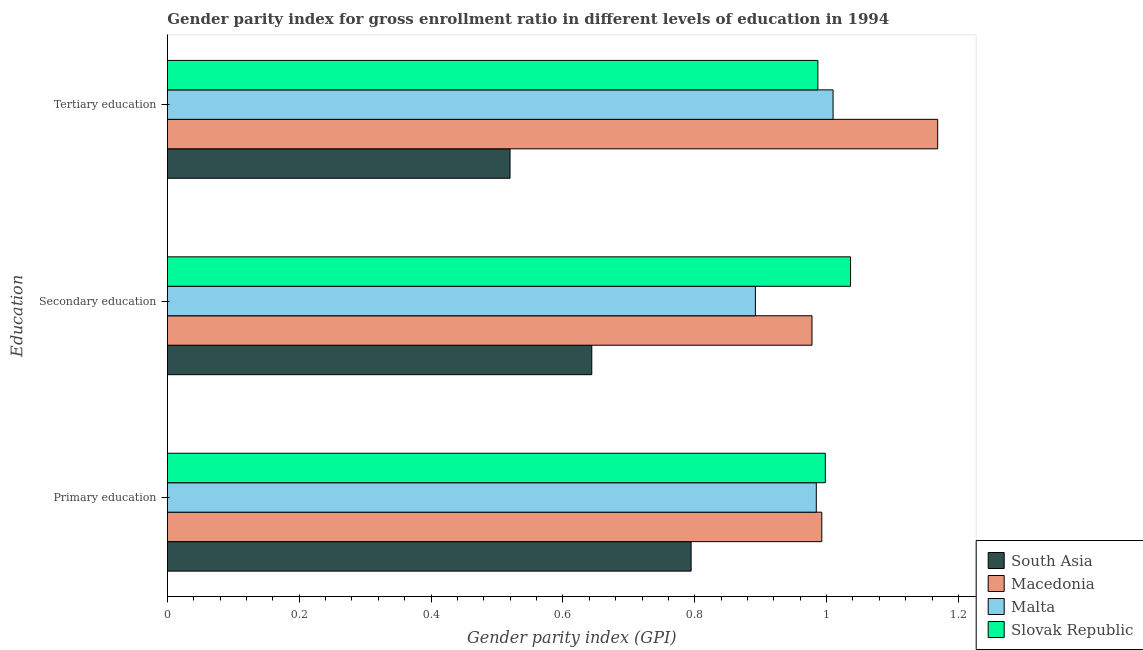How many different coloured bars are there?
Your answer should be compact. 4. How many bars are there on the 3rd tick from the bottom?
Provide a succinct answer. 4. What is the label of the 2nd group of bars from the top?
Offer a very short reply. Secondary education. What is the gender parity index in tertiary education in Macedonia?
Keep it short and to the point. 1.17. Across all countries, what is the maximum gender parity index in primary education?
Ensure brevity in your answer.  1. Across all countries, what is the minimum gender parity index in tertiary education?
Your response must be concise. 0.52. In which country was the gender parity index in secondary education maximum?
Provide a short and direct response. Slovak Republic. In which country was the gender parity index in secondary education minimum?
Your response must be concise. South Asia. What is the total gender parity index in tertiary education in the graph?
Provide a short and direct response. 3.68. What is the difference between the gender parity index in primary education in Slovak Republic and that in Macedonia?
Offer a terse response. 0.01. What is the difference between the gender parity index in tertiary education in Macedonia and the gender parity index in primary education in Malta?
Ensure brevity in your answer.  0.18. What is the average gender parity index in secondary education per country?
Keep it short and to the point. 0.89. What is the difference between the gender parity index in tertiary education and gender parity index in secondary education in Malta?
Ensure brevity in your answer.  0.12. In how many countries, is the gender parity index in secondary education greater than 0.36 ?
Your response must be concise. 4. What is the ratio of the gender parity index in tertiary education in South Asia to that in Slovak Republic?
Give a very brief answer. 0.53. Is the gender parity index in tertiary education in Macedonia less than that in Malta?
Offer a terse response. No. What is the difference between the highest and the second highest gender parity index in tertiary education?
Ensure brevity in your answer.  0.16. What is the difference between the highest and the lowest gender parity index in tertiary education?
Give a very brief answer. 0.65. What does the 1st bar from the top in Primary education represents?
Keep it short and to the point. Slovak Republic. What does the 4th bar from the bottom in Secondary education represents?
Offer a very short reply. Slovak Republic. Is it the case that in every country, the sum of the gender parity index in primary education and gender parity index in secondary education is greater than the gender parity index in tertiary education?
Make the answer very short. Yes. How many bars are there?
Ensure brevity in your answer.  12. Are all the bars in the graph horizontal?
Offer a very short reply. Yes. What is the difference between two consecutive major ticks on the X-axis?
Make the answer very short. 0.2. Does the graph contain any zero values?
Offer a terse response. No. Does the graph contain grids?
Provide a short and direct response. No. How are the legend labels stacked?
Offer a terse response. Vertical. What is the title of the graph?
Provide a succinct answer. Gender parity index for gross enrollment ratio in different levels of education in 1994. Does "American Samoa" appear as one of the legend labels in the graph?
Offer a terse response. No. What is the label or title of the X-axis?
Offer a terse response. Gender parity index (GPI). What is the label or title of the Y-axis?
Provide a succinct answer. Education. What is the Gender parity index (GPI) in South Asia in Primary education?
Provide a succinct answer. 0.79. What is the Gender parity index (GPI) in Macedonia in Primary education?
Your answer should be very brief. 0.99. What is the Gender parity index (GPI) of Malta in Primary education?
Offer a terse response. 0.98. What is the Gender parity index (GPI) in Slovak Republic in Primary education?
Provide a succinct answer. 1. What is the Gender parity index (GPI) in South Asia in Secondary education?
Your answer should be very brief. 0.64. What is the Gender parity index (GPI) of Macedonia in Secondary education?
Offer a very short reply. 0.98. What is the Gender parity index (GPI) in Malta in Secondary education?
Provide a short and direct response. 0.89. What is the Gender parity index (GPI) in Slovak Republic in Secondary education?
Your answer should be compact. 1.04. What is the Gender parity index (GPI) of South Asia in Tertiary education?
Keep it short and to the point. 0.52. What is the Gender parity index (GPI) in Macedonia in Tertiary education?
Offer a very short reply. 1.17. What is the Gender parity index (GPI) in Malta in Tertiary education?
Provide a short and direct response. 1.01. What is the Gender parity index (GPI) in Slovak Republic in Tertiary education?
Provide a short and direct response. 0.99. Across all Education, what is the maximum Gender parity index (GPI) in South Asia?
Offer a terse response. 0.79. Across all Education, what is the maximum Gender parity index (GPI) in Macedonia?
Offer a terse response. 1.17. Across all Education, what is the maximum Gender parity index (GPI) in Malta?
Make the answer very short. 1.01. Across all Education, what is the maximum Gender parity index (GPI) of Slovak Republic?
Make the answer very short. 1.04. Across all Education, what is the minimum Gender parity index (GPI) of South Asia?
Provide a short and direct response. 0.52. Across all Education, what is the minimum Gender parity index (GPI) in Macedonia?
Offer a very short reply. 0.98. Across all Education, what is the minimum Gender parity index (GPI) in Malta?
Ensure brevity in your answer.  0.89. Across all Education, what is the minimum Gender parity index (GPI) in Slovak Republic?
Your answer should be compact. 0.99. What is the total Gender parity index (GPI) in South Asia in the graph?
Your answer should be compact. 1.96. What is the total Gender parity index (GPI) in Macedonia in the graph?
Provide a short and direct response. 3.14. What is the total Gender parity index (GPI) in Malta in the graph?
Ensure brevity in your answer.  2.89. What is the total Gender parity index (GPI) in Slovak Republic in the graph?
Your answer should be compact. 3.02. What is the difference between the Gender parity index (GPI) of South Asia in Primary education and that in Secondary education?
Provide a short and direct response. 0.15. What is the difference between the Gender parity index (GPI) of Macedonia in Primary education and that in Secondary education?
Your answer should be compact. 0.01. What is the difference between the Gender parity index (GPI) in Malta in Primary education and that in Secondary education?
Your answer should be compact. 0.09. What is the difference between the Gender parity index (GPI) of Slovak Republic in Primary education and that in Secondary education?
Your answer should be very brief. -0.04. What is the difference between the Gender parity index (GPI) of South Asia in Primary education and that in Tertiary education?
Make the answer very short. 0.27. What is the difference between the Gender parity index (GPI) in Macedonia in Primary education and that in Tertiary education?
Provide a succinct answer. -0.18. What is the difference between the Gender parity index (GPI) of Malta in Primary education and that in Tertiary education?
Keep it short and to the point. -0.03. What is the difference between the Gender parity index (GPI) of Slovak Republic in Primary education and that in Tertiary education?
Provide a short and direct response. 0.01. What is the difference between the Gender parity index (GPI) in South Asia in Secondary education and that in Tertiary education?
Provide a succinct answer. 0.12. What is the difference between the Gender parity index (GPI) of Macedonia in Secondary education and that in Tertiary education?
Make the answer very short. -0.19. What is the difference between the Gender parity index (GPI) of Malta in Secondary education and that in Tertiary education?
Make the answer very short. -0.12. What is the difference between the Gender parity index (GPI) of Slovak Republic in Secondary education and that in Tertiary education?
Give a very brief answer. 0.05. What is the difference between the Gender parity index (GPI) in South Asia in Primary education and the Gender parity index (GPI) in Macedonia in Secondary education?
Provide a short and direct response. -0.18. What is the difference between the Gender parity index (GPI) in South Asia in Primary education and the Gender parity index (GPI) in Malta in Secondary education?
Provide a short and direct response. -0.1. What is the difference between the Gender parity index (GPI) of South Asia in Primary education and the Gender parity index (GPI) of Slovak Republic in Secondary education?
Keep it short and to the point. -0.24. What is the difference between the Gender parity index (GPI) of Macedonia in Primary education and the Gender parity index (GPI) of Malta in Secondary education?
Keep it short and to the point. 0.1. What is the difference between the Gender parity index (GPI) in Macedonia in Primary education and the Gender parity index (GPI) in Slovak Republic in Secondary education?
Keep it short and to the point. -0.04. What is the difference between the Gender parity index (GPI) in Malta in Primary education and the Gender parity index (GPI) in Slovak Republic in Secondary education?
Offer a very short reply. -0.05. What is the difference between the Gender parity index (GPI) of South Asia in Primary education and the Gender parity index (GPI) of Macedonia in Tertiary education?
Give a very brief answer. -0.37. What is the difference between the Gender parity index (GPI) in South Asia in Primary education and the Gender parity index (GPI) in Malta in Tertiary education?
Ensure brevity in your answer.  -0.22. What is the difference between the Gender parity index (GPI) of South Asia in Primary education and the Gender parity index (GPI) of Slovak Republic in Tertiary education?
Provide a succinct answer. -0.19. What is the difference between the Gender parity index (GPI) in Macedonia in Primary education and the Gender parity index (GPI) in Malta in Tertiary education?
Ensure brevity in your answer.  -0.02. What is the difference between the Gender parity index (GPI) in Macedonia in Primary education and the Gender parity index (GPI) in Slovak Republic in Tertiary education?
Keep it short and to the point. 0.01. What is the difference between the Gender parity index (GPI) of Malta in Primary education and the Gender parity index (GPI) of Slovak Republic in Tertiary education?
Ensure brevity in your answer.  -0. What is the difference between the Gender parity index (GPI) in South Asia in Secondary education and the Gender parity index (GPI) in Macedonia in Tertiary education?
Ensure brevity in your answer.  -0.52. What is the difference between the Gender parity index (GPI) in South Asia in Secondary education and the Gender parity index (GPI) in Malta in Tertiary education?
Offer a very short reply. -0.37. What is the difference between the Gender parity index (GPI) of South Asia in Secondary education and the Gender parity index (GPI) of Slovak Republic in Tertiary education?
Offer a terse response. -0.34. What is the difference between the Gender parity index (GPI) in Macedonia in Secondary education and the Gender parity index (GPI) in Malta in Tertiary education?
Provide a succinct answer. -0.03. What is the difference between the Gender parity index (GPI) of Macedonia in Secondary education and the Gender parity index (GPI) of Slovak Republic in Tertiary education?
Make the answer very short. -0.01. What is the difference between the Gender parity index (GPI) of Malta in Secondary education and the Gender parity index (GPI) of Slovak Republic in Tertiary education?
Offer a very short reply. -0.09. What is the average Gender parity index (GPI) of South Asia per Education?
Give a very brief answer. 0.65. What is the average Gender parity index (GPI) in Macedonia per Education?
Give a very brief answer. 1.05. What is the average Gender parity index (GPI) in Malta per Education?
Make the answer very short. 0.96. What is the average Gender parity index (GPI) in Slovak Republic per Education?
Ensure brevity in your answer.  1.01. What is the difference between the Gender parity index (GPI) in South Asia and Gender parity index (GPI) in Macedonia in Primary education?
Make the answer very short. -0.2. What is the difference between the Gender parity index (GPI) in South Asia and Gender parity index (GPI) in Malta in Primary education?
Your answer should be compact. -0.19. What is the difference between the Gender parity index (GPI) of South Asia and Gender parity index (GPI) of Slovak Republic in Primary education?
Offer a very short reply. -0.2. What is the difference between the Gender parity index (GPI) of Macedonia and Gender parity index (GPI) of Malta in Primary education?
Ensure brevity in your answer.  0.01. What is the difference between the Gender parity index (GPI) of Macedonia and Gender parity index (GPI) of Slovak Republic in Primary education?
Your answer should be very brief. -0.01. What is the difference between the Gender parity index (GPI) in Malta and Gender parity index (GPI) in Slovak Republic in Primary education?
Your response must be concise. -0.01. What is the difference between the Gender parity index (GPI) in South Asia and Gender parity index (GPI) in Macedonia in Secondary education?
Keep it short and to the point. -0.33. What is the difference between the Gender parity index (GPI) in South Asia and Gender parity index (GPI) in Malta in Secondary education?
Your answer should be very brief. -0.25. What is the difference between the Gender parity index (GPI) in South Asia and Gender parity index (GPI) in Slovak Republic in Secondary education?
Give a very brief answer. -0.39. What is the difference between the Gender parity index (GPI) in Macedonia and Gender parity index (GPI) in Malta in Secondary education?
Your response must be concise. 0.09. What is the difference between the Gender parity index (GPI) of Macedonia and Gender parity index (GPI) of Slovak Republic in Secondary education?
Provide a succinct answer. -0.06. What is the difference between the Gender parity index (GPI) in Malta and Gender parity index (GPI) in Slovak Republic in Secondary education?
Keep it short and to the point. -0.14. What is the difference between the Gender parity index (GPI) of South Asia and Gender parity index (GPI) of Macedonia in Tertiary education?
Keep it short and to the point. -0.65. What is the difference between the Gender parity index (GPI) of South Asia and Gender parity index (GPI) of Malta in Tertiary education?
Make the answer very short. -0.49. What is the difference between the Gender parity index (GPI) of South Asia and Gender parity index (GPI) of Slovak Republic in Tertiary education?
Offer a terse response. -0.47. What is the difference between the Gender parity index (GPI) in Macedonia and Gender parity index (GPI) in Malta in Tertiary education?
Ensure brevity in your answer.  0.16. What is the difference between the Gender parity index (GPI) of Macedonia and Gender parity index (GPI) of Slovak Republic in Tertiary education?
Your response must be concise. 0.18. What is the difference between the Gender parity index (GPI) in Malta and Gender parity index (GPI) in Slovak Republic in Tertiary education?
Offer a terse response. 0.02. What is the ratio of the Gender parity index (GPI) of South Asia in Primary education to that in Secondary education?
Give a very brief answer. 1.23. What is the ratio of the Gender parity index (GPI) of Macedonia in Primary education to that in Secondary education?
Offer a very short reply. 1.02. What is the ratio of the Gender parity index (GPI) in Malta in Primary education to that in Secondary education?
Your answer should be compact. 1.1. What is the ratio of the Gender parity index (GPI) of Slovak Republic in Primary education to that in Secondary education?
Provide a short and direct response. 0.96. What is the ratio of the Gender parity index (GPI) of South Asia in Primary education to that in Tertiary education?
Provide a short and direct response. 1.53. What is the ratio of the Gender parity index (GPI) in Macedonia in Primary education to that in Tertiary education?
Make the answer very short. 0.85. What is the ratio of the Gender parity index (GPI) of Malta in Primary education to that in Tertiary education?
Ensure brevity in your answer.  0.97. What is the ratio of the Gender parity index (GPI) in Slovak Republic in Primary education to that in Tertiary education?
Provide a short and direct response. 1.01. What is the ratio of the Gender parity index (GPI) of South Asia in Secondary education to that in Tertiary education?
Your response must be concise. 1.24. What is the ratio of the Gender parity index (GPI) of Macedonia in Secondary education to that in Tertiary education?
Offer a terse response. 0.84. What is the ratio of the Gender parity index (GPI) of Malta in Secondary education to that in Tertiary education?
Your response must be concise. 0.88. What is the ratio of the Gender parity index (GPI) in Slovak Republic in Secondary education to that in Tertiary education?
Offer a very short reply. 1.05. What is the difference between the highest and the second highest Gender parity index (GPI) of South Asia?
Your response must be concise. 0.15. What is the difference between the highest and the second highest Gender parity index (GPI) of Macedonia?
Make the answer very short. 0.18. What is the difference between the highest and the second highest Gender parity index (GPI) of Malta?
Provide a short and direct response. 0.03. What is the difference between the highest and the second highest Gender parity index (GPI) of Slovak Republic?
Keep it short and to the point. 0.04. What is the difference between the highest and the lowest Gender parity index (GPI) in South Asia?
Give a very brief answer. 0.27. What is the difference between the highest and the lowest Gender parity index (GPI) of Macedonia?
Your answer should be compact. 0.19. What is the difference between the highest and the lowest Gender parity index (GPI) of Malta?
Offer a very short reply. 0.12. What is the difference between the highest and the lowest Gender parity index (GPI) of Slovak Republic?
Offer a terse response. 0.05. 